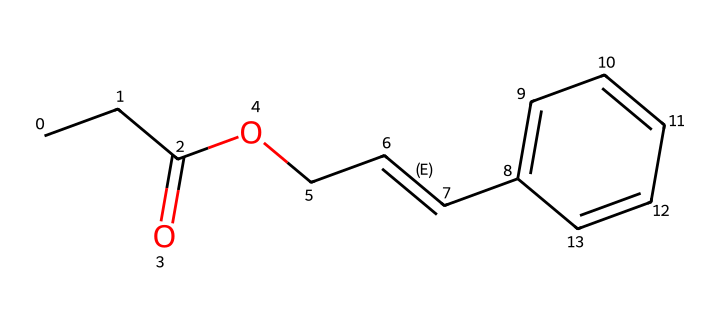What is the molecular formula for this compound? To determine the molecular formula, we count the atoms in the SMILES representation: there are 12 carbon atoms, 12 hydrogen atoms, and 2 oxygen atoms. Therefore, the formula is C12H12O2.
Answer: C12H12O2 How many double bonds are present in this compound? By examining the SMILES structure, there is one double bond in the carbon chain between the two carbons (the "/C=C/") and another double bond in the aromatic ring (between carbon atoms in the "C1=CC=CC=C1" part). Therefore, there are two double bonds.
Answer: 2 What type of functional groups are present in this compound? The SMILES representation indicates the presence of an ester group (from "C(=O)OC") and an alkene (from "/C=C/"). These define the functional groups in the molecule.
Answer: ester, alkene Is this compound likely to be soluble in water? Considering that the structure contains an ester group and a long carbon chain, which is hydrophobic, it is likely that the compound has limited solubility in water.
Answer: limited solubility What type of polymerizable structure does this compound have? The compound features a vinyl group ("C=C") which allows for polymerization through addition reactions, making it suitable for photoresists in photopolymer printing processes.
Answer: vinyl group 